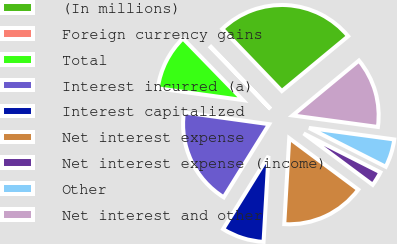Convert chart. <chart><loc_0><loc_0><loc_500><loc_500><pie_chart><fcel>(In millions)<fcel>Foreign currency gains<fcel>Total<fcel>Interest incurred (a)<fcel>Interest capitalized<fcel>Net interest expense<fcel>Net interest expense (income)<fcel>Other<fcel>Net interest and other<nl><fcel>26.16%<fcel>0.12%<fcel>10.53%<fcel>18.34%<fcel>7.93%<fcel>15.74%<fcel>2.72%<fcel>5.32%<fcel>13.14%<nl></chart> 